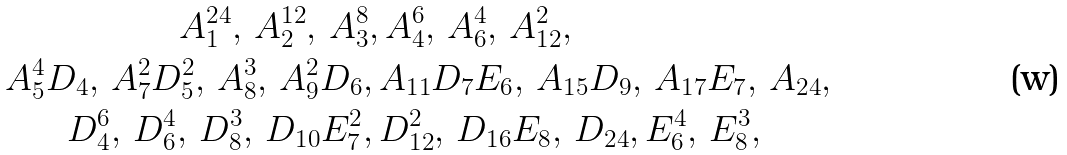Convert formula to latex. <formula><loc_0><loc_0><loc_500><loc_500>A _ { 1 } ^ { 2 4 } , \, A _ { 2 } ^ { 1 2 } , \, A _ { 3 } ^ { 8 } , & \, A _ { 4 } ^ { 6 } , \, A _ { 6 } ^ { 4 } , \, A _ { 1 2 } ^ { 2 } , \\ A _ { 5 } ^ { 4 } D _ { 4 } , \, A _ { 7 } ^ { 2 } D _ { 5 } ^ { 2 } , \, A _ { 8 } ^ { 3 } , \, A _ { 9 } ^ { 2 } D _ { 6 } , \, & A _ { 1 1 } D _ { 7 } E _ { 6 } , \, A _ { 1 5 } D _ { 9 } , \, A _ { 1 7 } E _ { 7 } , \, A _ { 2 4 } , \\ D _ { 4 } ^ { 6 } , \, D _ { 6 } ^ { 4 } , \, D _ { 8 } ^ { 3 } , \, D _ { 1 0 } E _ { 7 } ^ { 2 } , \, & D _ { 1 2 } ^ { 2 } , \, D _ { 1 6 } E _ { 8 } , \, D _ { 2 4 } , E _ { 6 } ^ { 4 } , \, E _ { 8 } ^ { 3 } ,</formula> 